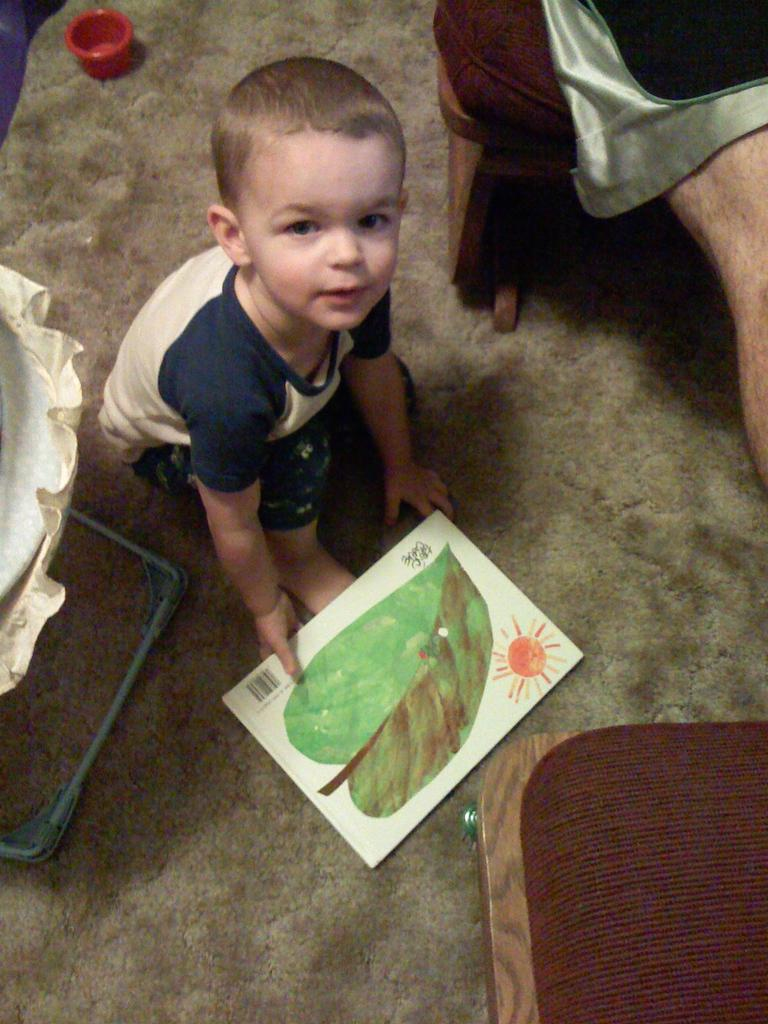What is the person holding in the image? The person is holding a white color sheet in the image. What can be seen on the white color sheet? There is a leaf and the sun visible on the white color sheet. What is the person's immediate environment like in the image? There are a few objects around the person. Is the person driving a vehicle in the image? No, there is no vehicle or indication of driving in the image. Can you see any quicksand in the image? No, there is no quicksand present in the image. 